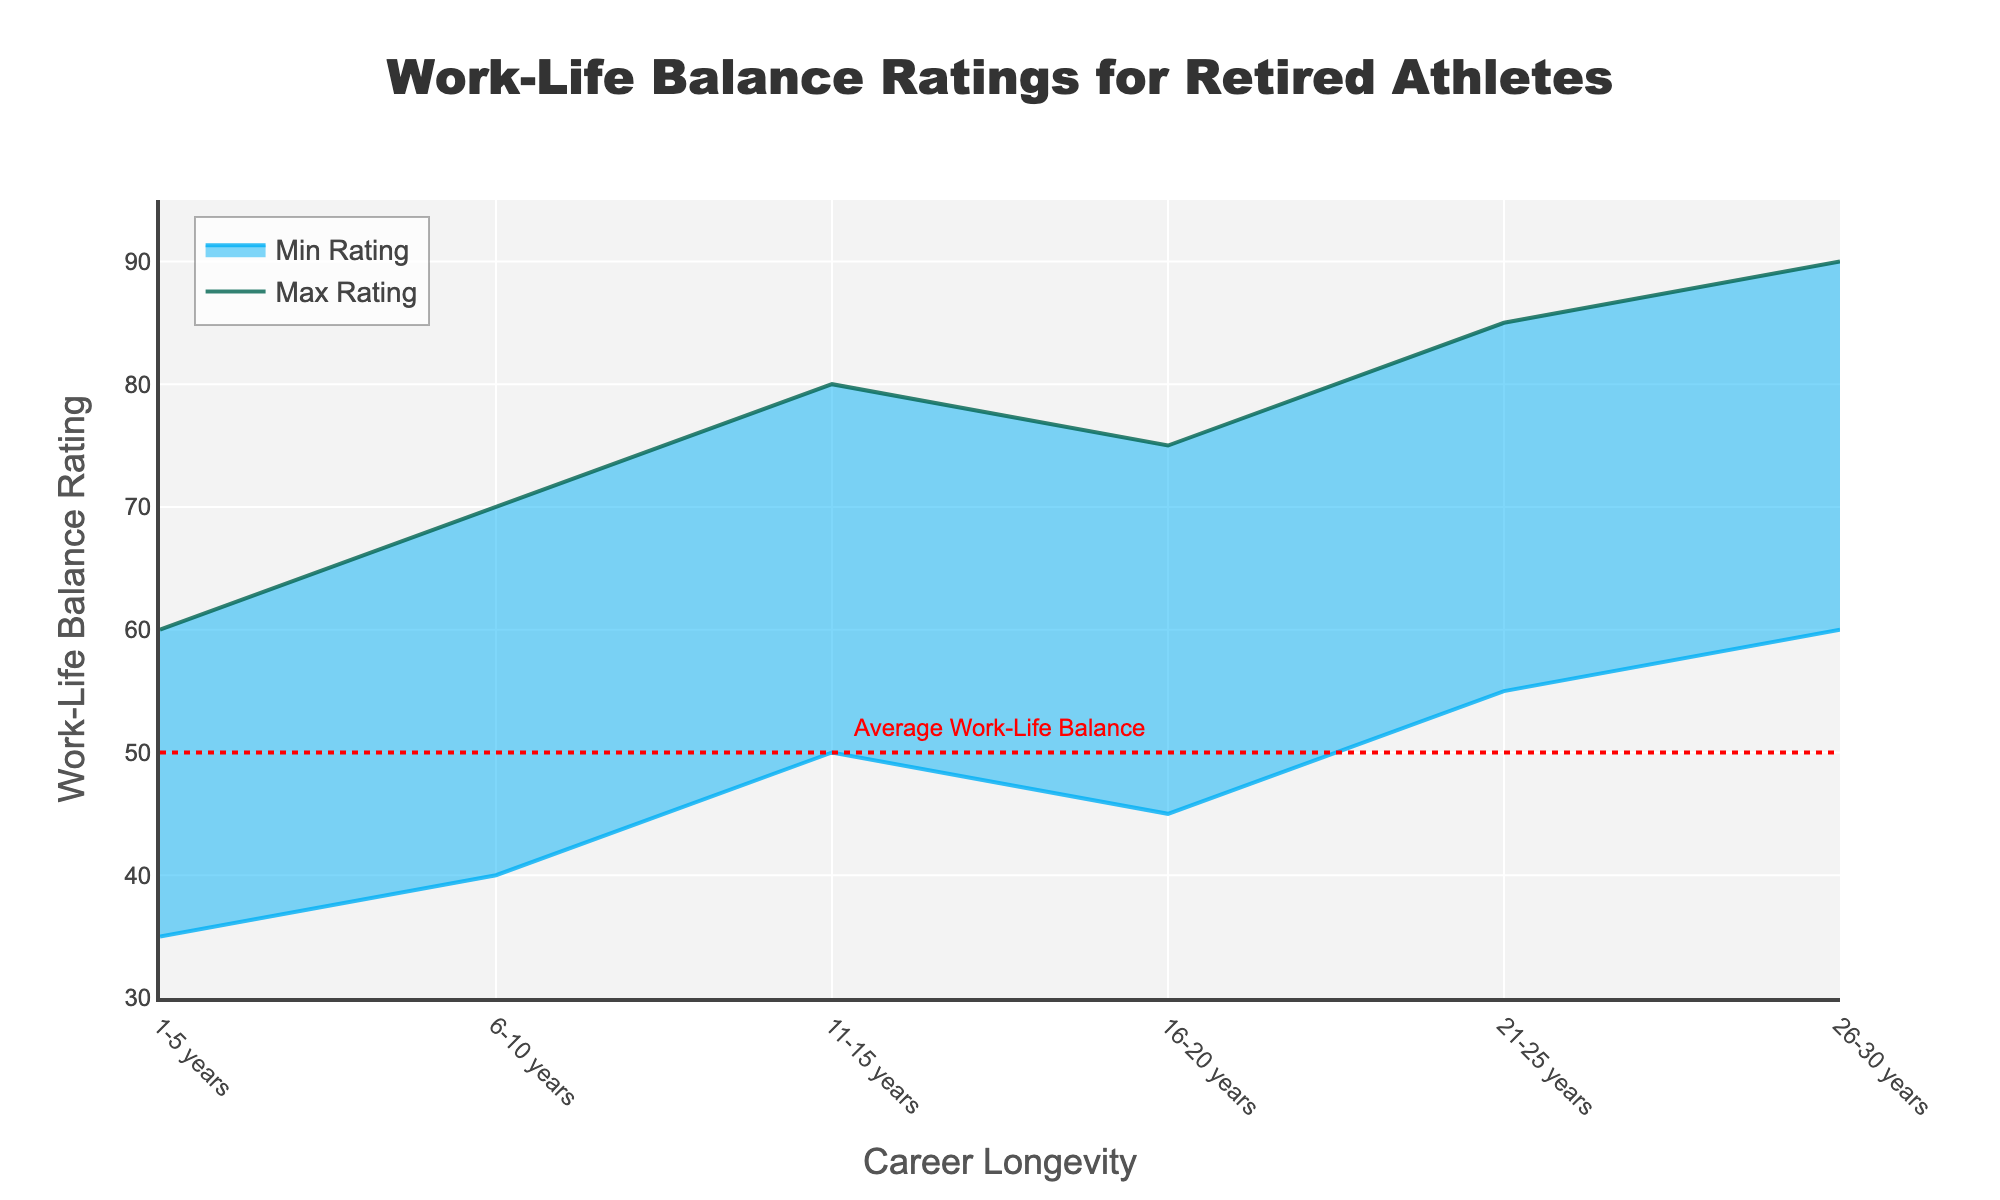What is the title of the figure? The title typically appears at the top of the figure and provides a descriptive summary of the data being visualized. The title in this figure is "Work-Life Balance Ratings for Retired Athletes".
Answer: Work-Life Balance Ratings for Retired Athletes What is the lowest Work-Life Balance rating for athletes with 26-30 years of career longevity? Locate the "26-30 years" category on the x-axis, then find the corresponding minimum Work-Life Balance rating on the y-axis. The minimum rating in this range is 60.
Answer: 60 What is the maximum Work-Life Balance rating for athletes with 1-5 years of career longevity? Find the "1-5 years" on the x-axis and trace it vertically to the maximum rating line, which corresponds to 60 on the y-axis.
Answer: 60 What is the average Work-Life Balance rating for athletes with 16-20 years of career longevity? For the "16-20 years" category, the minimum rating is 45, and the maximum rating is 75. To find the average: (45 + 75) / 2 = 120 / 2 = 60.
Answer: 60 Which career longevity group has the highest minimum Work-Life Balance rating? Look at all the bars that represent minimum ratings and identify the tallest one. At "26-30 years", the minimum rating bar goes up to 60, which is the highest among all groups.
Answer: 26-30 years How much higher is the minimum Work-Life Balance rating for athletes with 21-25 years compared to those with 1-5 years of career longevity? The minimum rating for "21-25 years" is 55, and for "1-5 years" is 35. Calculate the difference: 55 - 35 = 20.
Answer: 20 Which career longevity group has the widest range of Work-Life Balance ratings? To determine the range, subtract the minimum from the maximum rating for each group. The widest range is for "26-30 years": 90 - 60 = 30.
Answer: 26-30 years What does the red dashed line in the figure represent? The red dashed line is labeled "Average Work-Life Balance" and is located at the 50 mark on the y-axis.
Answer: Average Work-Life Balance How does the maximum rating for athletes with 21-25 years compare to the maximum rating for athletes with 6-10 years? The maximum rating for "21-25 years" is 85, whereas for "6-10 years" it is 70. By comparing 85 and 70, we see that 85 > 70.
Answer: Higher What is the trend of minimum Work-Life Balance ratings as career longevity increases? To identify the trend, observe how the minimum ratings change as you move from left to right along the x-axis. The minimum ratings generally increase from 35 to 60 as career longevity increases.
Answer: Increasing 